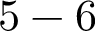<formula> <loc_0><loc_0><loc_500><loc_500>5 - 6</formula> 